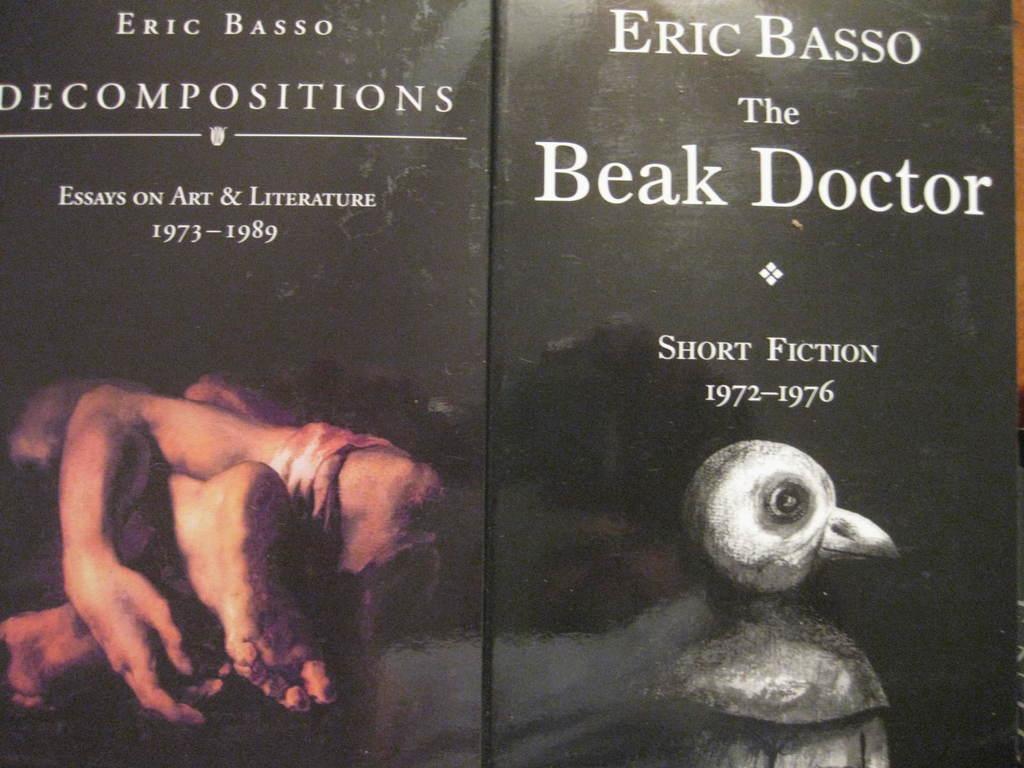Can you describe this image briefly? In this image I can see two books. On the book which is on the right side, I can see some text and at the depiction of a bird. On the book which is on the left side, I can see some text and legs and hands of a person. 